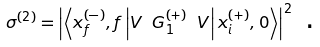Convert formula to latex. <formula><loc_0><loc_0><loc_500><loc_500>\sigma ^ { \left ( 2 \right ) } = \left | \left \langle x _ { f } ^ { \left ( - \right ) } , f \left | V \text { } G _ { 1 } ^ { \left ( + \right ) } \text { } V \right | x _ { i } ^ { \left ( + \right ) } , 0 \right \rangle \right | ^ { 2 } \text { .}</formula> 